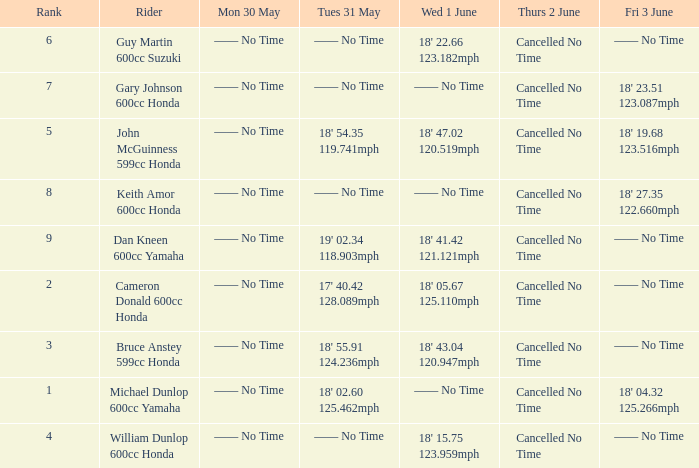What is the rank of the rider whose Tues 31 May time was 19' 02.34 118.903mph? 9.0. 